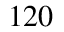<formula> <loc_0><loc_0><loc_500><loc_500>^ { 1 2 0 }</formula> 